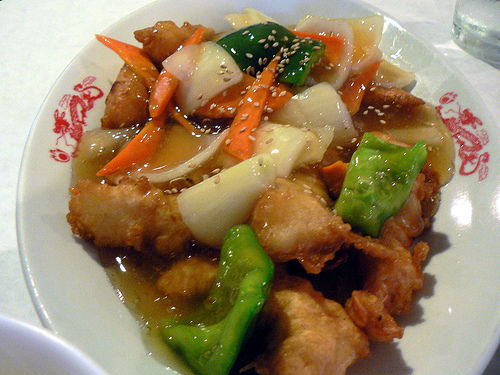<image>
Can you confirm if the food is behind the glass? No. The food is not behind the glass. From this viewpoint, the food appears to be positioned elsewhere in the scene. Where is the oni in relation to the pepper? Is it in front of the pepper? No. The oni is not in front of the pepper. The spatial positioning shows a different relationship between these objects. 